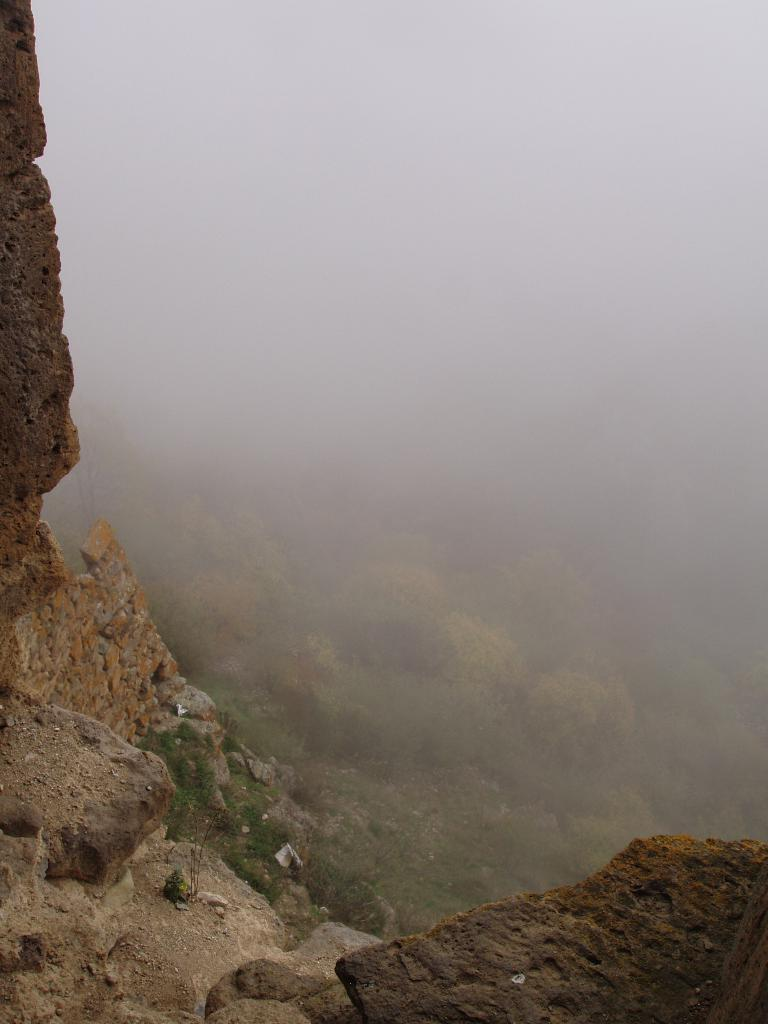What type of natural elements can be seen in the image? There are trees and rocks in the image. What is visible in the background of the image? The sky is visible in the background of the image. What type of horn can be seen on the horse in the image? There is no horse or horn present in the image. What invention is being used by the trees in the image? There is no invention associated with the trees in the image. 